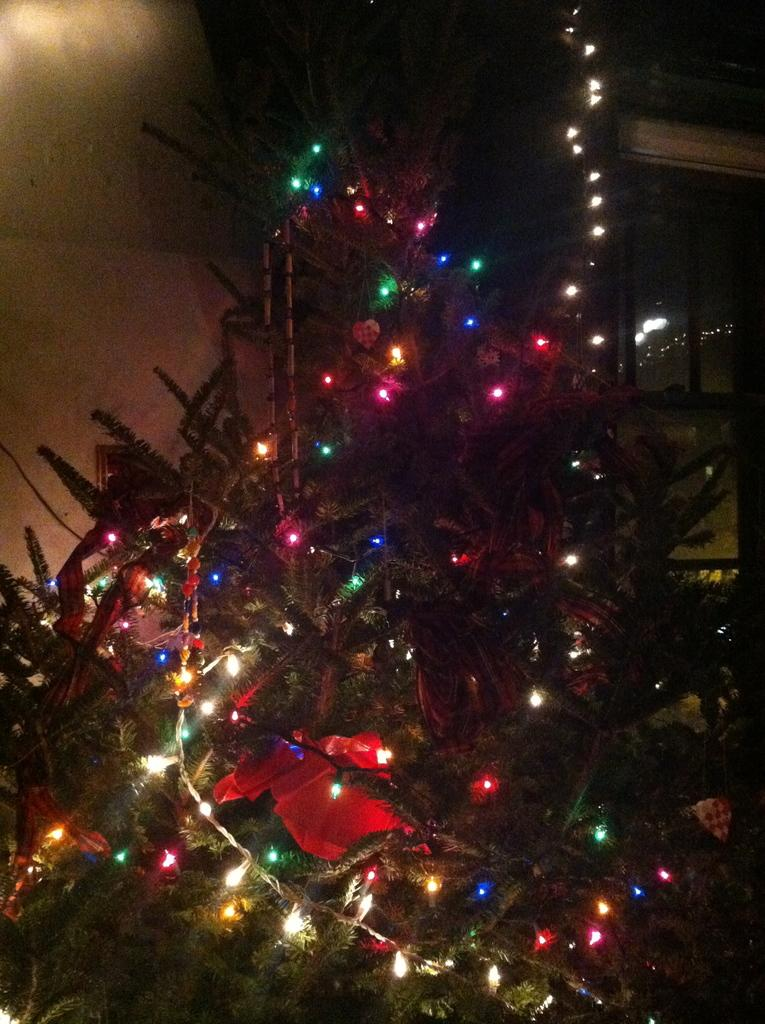What is the main object in the image? There is a tree in the image. How is the tree in the image decorated? The tree is decorated with rope lights. Are there any additional decorations on the tree? Yes, the tree has decorative items. What can be seen in the background of the image? There is a wall in the background of the image. What type of suit is the pest wearing in the image? There is no pest or suit present in the image. 